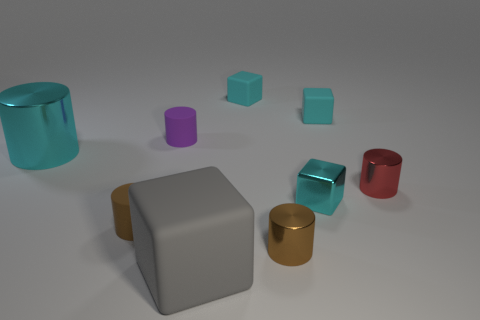Can you describe the objects on the right side of the image? Certainly! On the right side, there are three objects: a reflective red cylinder, a small blue cube, and a shiny gold cylinder. The red cylinder and gold cylinder both have a smooth, metallic finish, while the small blue cube has a matte finish. 